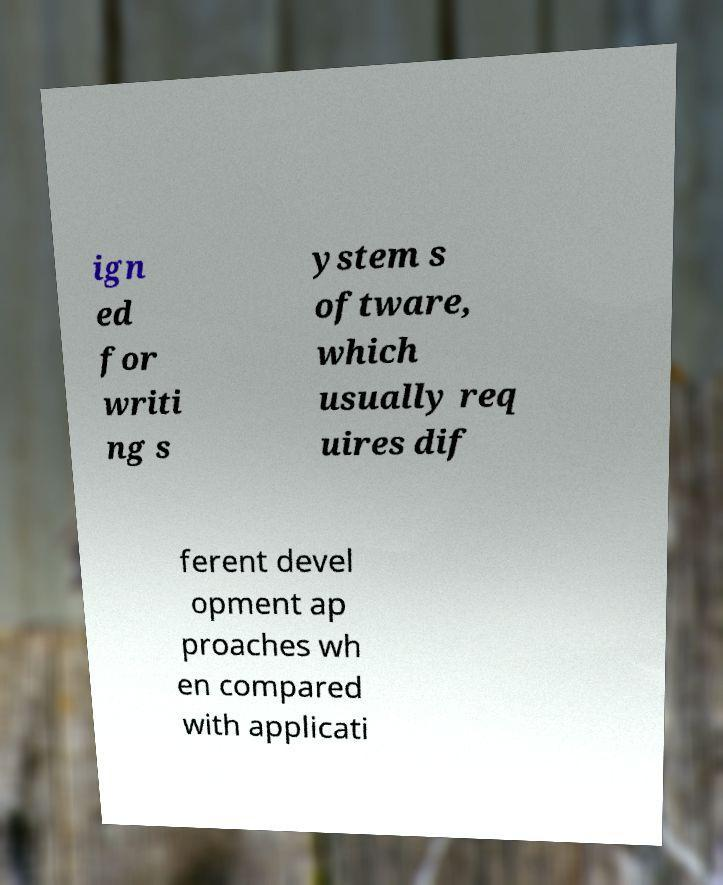Could you extract and type out the text from this image? ign ed for writi ng s ystem s oftware, which usually req uires dif ferent devel opment ap proaches wh en compared with applicati 